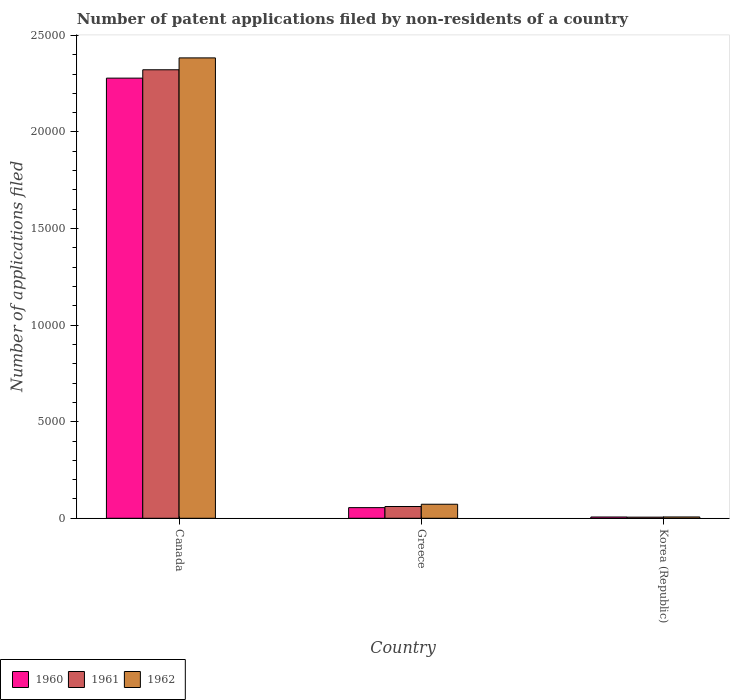How many different coloured bars are there?
Your answer should be very brief. 3. How many groups of bars are there?
Provide a succinct answer. 3. Are the number of bars per tick equal to the number of legend labels?
Keep it short and to the point. Yes. What is the number of applications filed in 1962 in Greece?
Your answer should be very brief. 726. Across all countries, what is the maximum number of applications filed in 1961?
Offer a very short reply. 2.32e+04. In which country was the number of applications filed in 1961 maximum?
Offer a very short reply. Canada. In which country was the number of applications filed in 1962 minimum?
Give a very brief answer. Korea (Republic). What is the total number of applications filed in 1961 in the graph?
Provide a succinct answer. 2.39e+04. What is the difference between the number of applications filed in 1960 in Canada and that in Korea (Republic)?
Your answer should be very brief. 2.27e+04. What is the difference between the number of applications filed in 1961 in Canada and the number of applications filed in 1962 in Korea (Republic)?
Give a very brief answer. 2.32e+04. What is the average number of applications filed in 1962 per country?
Make the answer very short. 8209.33. In how many countries, is the number of applications filed in 1961 greater than 11000?
Your answer should be very brief. 1. What is the ratio of the number of applications filed in 1961 in Canada to that in Korea (Republic)?
Provide a short and direct response. 400.33. What is the difference between the highest and the second highest number of applications filed in 1962?
Make the answer very short. 2.38e+04. What is the difference between the highest and the lowest number of applications filed in 1961?
Offer a very short reply. 2.32e+04. How many countries are there in the graph?
Ensure brevity in your answer.  3. What is the difference between two consecutive major ticks on the Y-axis?
Provide a short and direct response. 5000. Are the values on the major ticks of Y-axis written in scientific E-notation?
Your answer should be very brief. No. Where does the legend appear in the graph?
Your response must be concise. Bottom left. How are the legend labels stacked?
Your answer should be very brief. Horizontal. What is the title of the graph?
Ensure brevity in your answer.  Number of patent applications filed by non-residents of a country. What is the label or title of the Y-axis?
Give a very brief answer. Number of applications filed. What is the Number of applications filed in 1960 in Canada?
Keep it short and to the point. 2.28e+04. What is the Number of applications filed of 1961 in Canada?
Your answer should be compact. 2.32e+04. What is the Number of applications filed of 1962 in Canada?
Your answer should be compact. 2.38e+04. What is the Number of applications filed of 1960 in Greece?
Offer a terse response. 551. What is the Number of applications filed in 1961 in Greece?
Give a very brief answer. 609. What is the Number of applications filed of 1962 in Greece?
Ensure brevity in your answer.  726. What is the Number of applications filed of 1960 in Korea (Republic)?
Ensure brevity in your answer.  66. What is the Number of applications filed in 1962 in Korea (Republic)?
Keep it short and to the point. 68. Across all countries, what is the maximum Number of applications filed of 1960?
Your answer should be compact. 2.28e+04. Across all countries, what is the maximum Number of applications filed of 1961?
Your answer should be very brief. 2.32e+04. Across all countries, what is the maximum Number of applications filed of 1962?
Offer a very short reply. 2.38e+04. Across all countries, what is the minimum Number of applications filed in 1960?
Your answer should be very brief. 66. Across all countries, what is the minimum Number of applications filed in 1961?
Give a very brief answer. 58. Across all countries, what is the minimum Number of applications filed of 1962?
Your answer should be compact. 68. What is the total Number of applications filed in 1960 in the graph?
Offer a terse response. 2.34e+04. What is the total Number of applications filed of 1961 in the graph?
Ensure brevity in your answer.  2.39e+04. What is the total Number of applications filed of 1962 in the graph?
Offer a terse response. 2.46e+04. What is the difference between the Number of applications filed of 1960 in Canada and that in Greece?
Your answer should be very brief. 2.22e+04. What is the difference between the Number of applications filed in 1961 in Canada and that in Greece?
Provide a succinct answer. 2.26e+04. What is the difference between the Number of applications filed of 1962 in Canada and that in Greece?
Keep it short and to the point. 2.31e+04. What is the difference between the Number of applications filed in 1960 in Canada and that in Korea (Republic)?
Provide a short and direct response. 2.27e+04. What is the difference between the Number of applications filed of 1961 in Canada and that in Korea (Republic)?
Offer a very short reply. 2.32e+04. What is the difference between the Number of applications filed of 1962 in Canada and that in Korea (Republic)?
Your response must be concise. 2.38e+04. What is the difference between the Number of applications filed in 1960 in Greece and that in Korea (Republic)?
Make the answer very short. 485. What is the difference between the Number of applications filed in 1961 in Greece and that in Korea (Republic)?
Provide a short and direct response. 551. What is the difference between the Number of applications filed of 1962 in Greece and that in Korea (Republic)?
Provide a succinct answer. 658. What is the difference between the Number of applications filed in 1960 in Canada and the Number of applications filed in 1961 in Greece?
Keep it short and to the point. 2.22e+04. What is the difference between the Number of applications filed in 1960 in Canada and the Number of applications filed in 1962 in Greece?
Your answer should be compact. 2.21e+04. What is the difference between the Number of applications filed in 1961 in Canada and the Number of applications filed in 1962 in Greece?
Your response must be concise. 2.25e+04. What is the difference between the Number of applications filed in 1960 in Canada and the Number of applications filed in 1961 in Korea (Republic)?
Offer a very short reply. 2.27e+04. What is the difference between the Number of applications filed of 1960 in Canada and the Number of applications filed of 1962 in Korea (Republic)?
Make the answer very short. 2.27e+04. What is the difference between the Number of applications filed in 1961 in Canada and the Number of applications filed in 1962 in Korea (Republic)?
Offer a very short reply. 2.32e+04. What is the difference between the Number of applications filed in 1960 in Greece and the Number of applications filed in 1961 in Korea (Republic)?
Provide a succinct answer. 493. What is the difference between the Number of applications filed of 1960 in Greece and the Number of applications filed of 1962 in Korea (Republic)?
Your answer should be compact. 483. What is the difference between the Number of applications filed of 1961 in Greece and the Number of applications filed of 1962 in Korea (Republic)?
Ensure brevity in your answer.  541. What is the average Number of applications filed in 1960 per country?
Offer a very short reply. 7801. What is the average Number of applications filed in 1961 per country?
Make the answer very short. 7962. What is the average Number of applications filed in 1962 per country?
Offer a terse response. 8209.33. What is the difference between the Number of applications filed of 1960 and Number of applications filed of 1961 in Canada?
Provide a short and direct response. -433. What is the difference between the Number of applications filed in 1960 and Number of applications filed in 1962 in Canada?
Provide a succinct answer. -1048. What is the difference between the Number of applications filed in 1961 and Number of applications filed in 1962 in Canada?
Make the answer very short. -615. What is the difference between the Number of applications filed of 1960 and Number of applications filed of 1961 in Greece?
Ensure brevity in your answer.  -58. What is the difference between the Number of applications filed of 1960 and Number of applications filed of 1962 in Greece?
Offer a terse response. -175. What is the difference between the Number of applications filed in 1961 and Number of applications filed in 1962 in Greece?
Your answer should be compact. -117. What is the difference between the Number of applications filed of 1960 and Number of applications filed of 1961 in Korea (Republic)?
Offer a very short reply. 8. What is the difference between the Number of applications filed of 1961 and Number of applications filed of 1962 in Korea (Republic)?
Provide a short and direct response. -10. What is the ratio of the Number of applications filed of 1960 in Canada to that in Greece?
Provide a succinct answer. 41.35. What is the ratio of the Number of applications filed in 1961 in Canada to that in Greece?
Your answer should be very brief. 38.13. What is the ratio of the Number of applications filed of 1962 in Canada to that in Greece?
Ensure brevity in your answer.  32.83. What is the ratio of the Number of applications filed in 1960 in Canada to that in Korea (Republic)?
Provide a short and direct response. 345.24. What is the ratio of the Number of applications filed of 1961 in Canada to that in Korea (Republic)?
Your response must be concise. 400.33. What is the ratio of the Number of applications filed of 1962 in Canada to that in Korea (Republic)?
Your response must be concise. 350.5. What is the ratio of the Number of applications filed of 1960 in Greece to that in Korea (Republic)?
Make the answer very short. 8.35. What is the ratio of the Number of applications filed in 1961 in Greece to that in Korea (Republic)?
Make the answer very short. 10.5. What is the ratio of the Number of applications filed of 1962 in Greece to that in Korea (Republic)?
Your answer should be very brief. 10.68. What is the difference between the highest and the second highest Number of applications filed of 1960?
Provide a succinct answer. 2.22e+04. What is the difference between the highest and the second highest Number of applications filed of 1961?
Offer a terse response. 2.26e+04. What is the difference between the highest and the second highest Number of applications filed in 1962?
Ensure brevity in your answer.  2.31e+04. What is the difference between the highest and the lowest Number of applications filed in 1960?
Ensure brevity in your answer.  2.27e+04. What is the difference between the highest and the lowest Number of applications filed in 1961?
Keep it short and to the point. 2.32e+04. What is the difference between the highest and the lowest Number of applications filed of 1962?
Your response must be concise. 2.38e+04. 